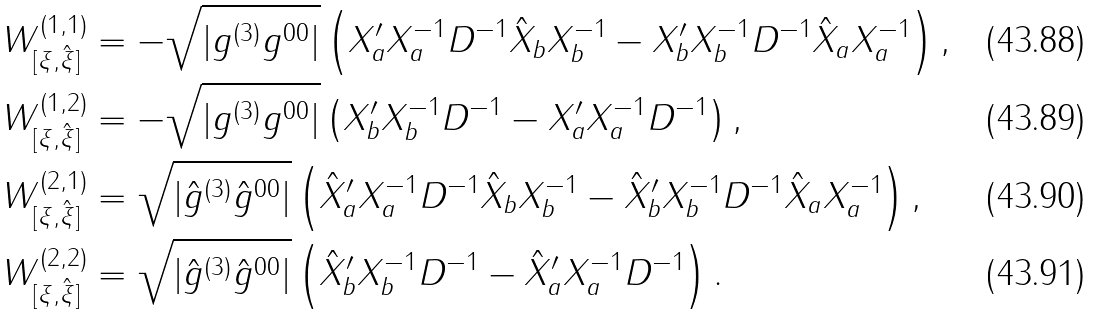Convert formula to latex. <formula><loc_0><loc_0><loc_500><loc_500>W _ { [ \xi , \hat { \xi } ] } ^ { ( 1 , 1 ) } & = - \sqrt { | g ^ { ( 3 ) } g ^ { 0 0 } | } \left ( X _ { a } ^ { \prime } X _ { a } ^ { - 1 } D ^ { - 1 } \hat { X } _ { b } X _ { b } ^ { - 1 } - X _ { b } ^ { \prime } X _ { b } ^ { - 1 } D ^ { - 1 } \hat { X } _ { a } X _ { a } ^ { - 1 } \right ) , \\ W _ { [ \xi , \hat { \xi } ] } ^ { ( 1 , 2 ) } & = - \sqrt { | g ^ { ( 3 ) } g ^ { 0 0 } | } \left ( X _ { b } ^ { \prime } X _ { b } ^ { - 1 } D ^ { - 1 } - X _ { a } ^ { \prime } X _ { a } ^ { - 1 } D ^ { - 1 } \right ) , \\ W _ { [ \xi , \hat { \xi } ] } ^ { ( 2 , 1 ) } & = \sqrt { | \hat { g } ^ { ( 3 ) } \hat { g } ^ { 0 0 } | } \left ( \hat { X } _ { a } ^ { \prime } X _ { a } ^ { - 1 } D ^ { - 1 } \hat { X } _ { b } X _ { b } ^ { - 1 } - \hat { X } _ { b } ^ { \prime } X _ { b } ^ { - 1 } D ^ { - 1 } \hat { X } _ { a } X _ { a } ^ { - 1 } \right ) , \\ W _ { [ \xi , \hat { \xi } ] } ^ { ( 2 , 2 ) } & = \sqrt { | \hat { g } ^ { ( 3 ) } \hat { g } ^ { 0 0 } | } \left ( \hat { X } _ { b } ^ { \prime } X _ { b } ^ { - 1 } D ^ { - 1 } - \hat { X } _ { a } ^ { \prime } X _ { a } ^ { - 1 } D ^ { - 1 } \right ) .</formula> 